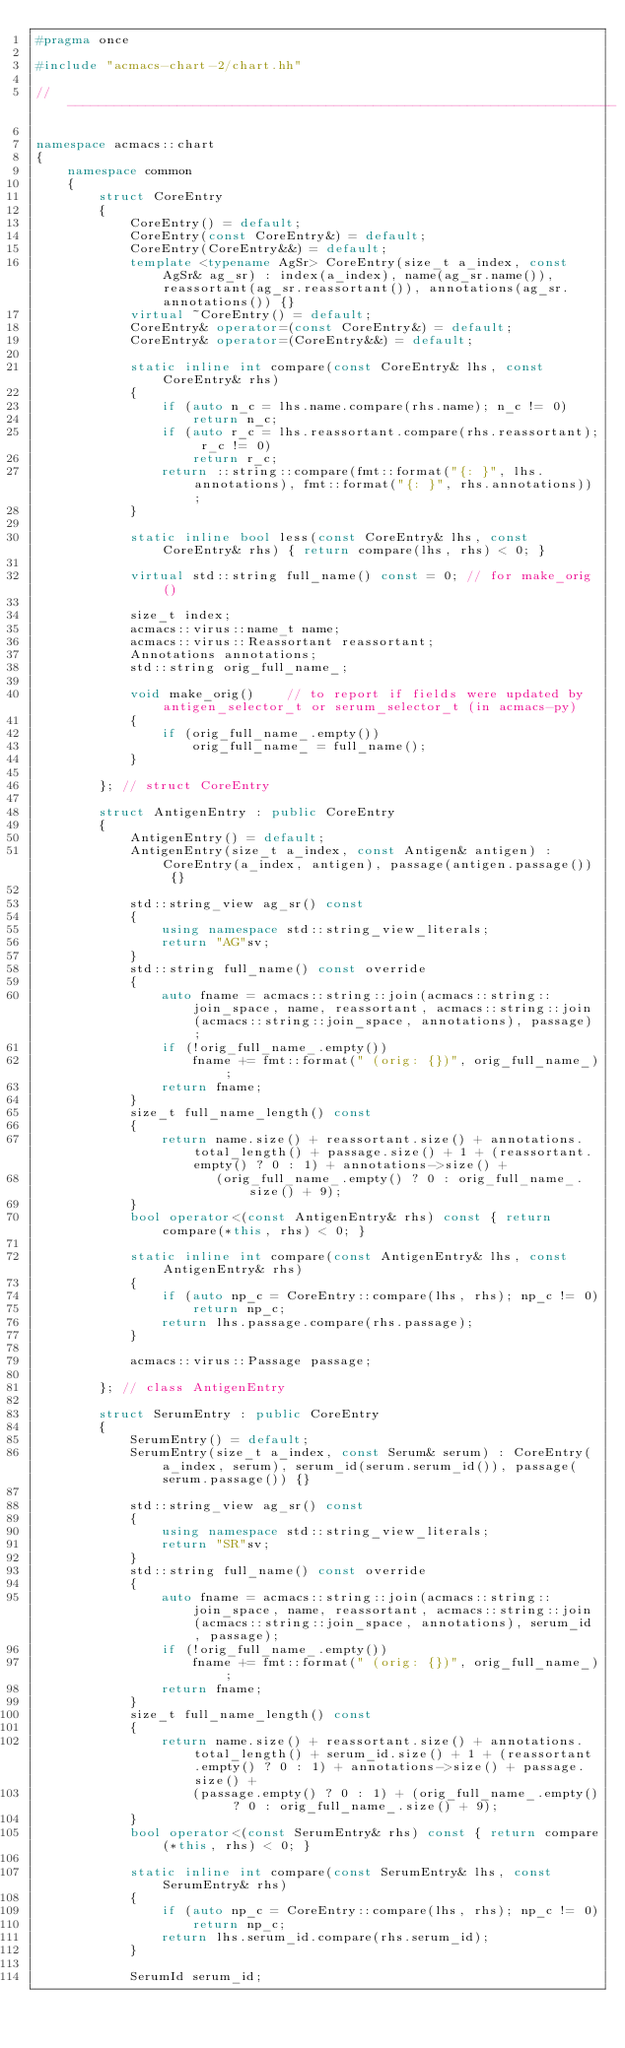<code> <loc_0><loc_0><loc_500><loc_500><_C++_>#pragma once

#include "acmacs-chart-2/chart.hh"

// ----------------------------------------------------------------------

namespace acmacs::chart
{
    namespace common
    {
        struct CoreEntry
        {
            CoreEntry() = default;
            CoreEntry(const CoreEntry&) = default;
            CoreEntry(CoreEntry&&) = default;
            template <typename AgSr> CoreEntry(size_t a_index, const AgSr& ag_sr) : index(a_index), name(ag_sr.name()), reassortant(ag_sr.reassortant()), annotations(ag_sr.annotations()) {}
            virtual ~CoreEntry() = default;
            CoreEntry& operator=(const CoreEntry&) = default;
            CoreEntry& operator=(CoreEntry&&) = default;

            static inline int compare(const CoreEntry& lhs, const CoreEntry& rhs)
            {
                if (auto n_c = lhs.name.compare(rhs.name); n_c != 0)
                    return n_c;
                if (auto r_c = lhs.reassortant.compare(rhs.reassortant); r_c != 0)
                    return r_c;
                return ::string::compare(fmt::format("{: }", lhs.annotations), fmt::format("{: }", rhs.annotations));
            }

            static inline bool less(const CoreEntry& lhs, const CoreEntry& rhs) { return compare(lhs, rhs) < 0; }

            virtual std::string full_name() const = 0; // for make_orig()

            size_t index;
            acmacs::virus::name_t name;
            acmacs::virus::Reassortant reassortant;
            Annotations annotations;
            std::string orig_full_name_;

            void make_orig()    // to report if fields were updated by antigen_selector_t or serum_selector_t (in acmacs-py)
            {
                if (orig_full_name_.empty())
                    orig_full_name_ = full_name();
            }

        }; // struct CoreEntry

        struct AntigenEntry : public CoreEntry
        {
            AntigenEntry() = default;
            AntigenEntry(size_t a_index, const Antigen& antigen) : CoreEntry(a_index, antigen), passage(antigen.passage()) {}

            std::string_view ag_sr() const
            {
                using namespace std::string_view_literals;
                return "AG"sv;
            }
            std::string full_name() const override
            {
                auto fname = acmacs::string::join(acmacs::string::join_space, name, reassortant, acmacs::string::join(acmacs::string::join_space, annotations), passage);
                if (!orig_full_name_.empty())
                    fname += fmt::format(" (orig: {})", orig_full_name_);
                return fname;
            }
            size_t full_name_length() const
            {
                return name.size() + reassortant.size() + annotations.total_length() + passage.size() + 1 + (reassortant.empty() ? 0 : 1) + annotations->size() +
                       (orig_full_name_.empty() ? 0 : orig_full_name_.size() + 9);
            }
            bool operator<(const AntigenEntry& rhs) const { return compare(*this, rhs) < 0; }

            static inline int compare(const AntigenEntry& lhs, const AntigenEntry& rhs)
            {
                if (auto np_c = CoreEntry::compare(lhs, rhs); np_c != 0)
                    return np_c;
                return lhs.passage.compare(rhs.passage);
            }

            acmacs::virus::Passage passage;

        }; // class AntigenEntry

        struct SerumEntry : public CoreEntry
        {
            SerumEntry() = default;
            SerumEntry(size_t a_index, const Serum& serum) : CoreEntry(a_index, serum), serum_id(serum.serum_id()), passage(serum.passage()) {}

            std::string_view ag_sr() const
            {
                using namespace std::string_view_literals;
                return "SR"sv;
            }
            std::string full_name() const override
            {
                auto fname = acmacs::string::join(acmacs::string::join_space, name, reassortant, acmacs::string::join(acmacs::string::join_space, annotations), serum_id, passage);
                if (!orig_full_name_.empty())
                    fname += fmt::format(" (orig: {})", orig_full_name_);
                return fname;
            }
            size_t full_name_length() const
            {
                return name.size() + reassortant.size() + annotations.total_length() + serum_id.size() + 1 + (reassortant.empty() ? 0 : 1) + annotations->size() + passage.size() +
                    (passage.empty() ? 0 : 1) + (orig_full_name_.empty() ? 0 : orig_full_name_.size() + 9);
            }
            bool operator<(const SerumEntry& rhs) const { return compare(*this, rhs) < 0; }

            static inline int compare(const SerumEntry& lhs, const SerumEntry& rhs)
            {
                if (auto np_c = CoreEntry::compare(lhs, rhs); np_c != 0)
                    return np_c;
                return lhs.serum_id.compare(rhs.serum_id);
            }

            SerumId serum_id;</code> 